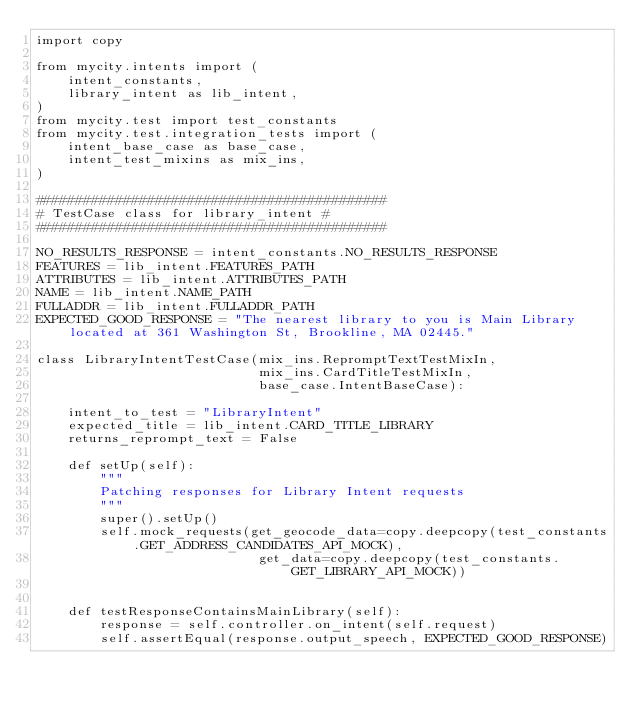Convert code to text. <code><loc_0><loc_0><loc_500><loc_500><_Python_>import copy

from mycity.intents import (
    intent_constants,
    library_intent as lib_intent,
)
from mycity.test import test_constants
from mycity.test.integration_tests import (
    intent_base_case as base_case,
    intent_test_mixins as mix_ins,
)

############################################
# TestCase class for library_intent #
############################################

NO_RESULTS_RESPONSE = intent_constants.NO_RESULTS_RESPONSE
FEATURES = lib_intent.FEATURES_PATH
ATTRIBUTES = lib_intent.ATTRIBUTES_PATH
NAME = lib_intent.NAME_PATH
FULLADDR = lib_intent.FULLADDR_PATH
EXPECTED_GOOD_RESPONSE = "The nearest library to you is Main Library located at 361 Washington St, Brookline, MA 02445."

class LibraryIntentTestCase(mix_ins.RepromptTextTestMixIn,
                            mix_ins.CardTitleTestMixIn,
                            base_case.IntentBaseCase):
    
    intent_to_test = "LibraryIntent"
    expected_title = lib_intent.CARD_TITLE_LIBRARY
    returns_reprompt_text = False

    def setUp(self):
        """
        Patching responses for Library Intent requests
        """
        super().setUp()
        self.mock_requests(get_geocode_data=copy.deepcopy(test_constants.GET_ADDRESS_CANDIDATES_API_MOCK), 
                            get_data=copy.deepcopy(test_constants.GET_LIBRARY_API_MOCK))


    def testResponseContainsMainLibrary(self):
        response = self.controller.on_intent(self.request)
        self.assertEqual(response.output_speech, EXPECTED_GOOD_RESPONSE)
            
                        </code> 